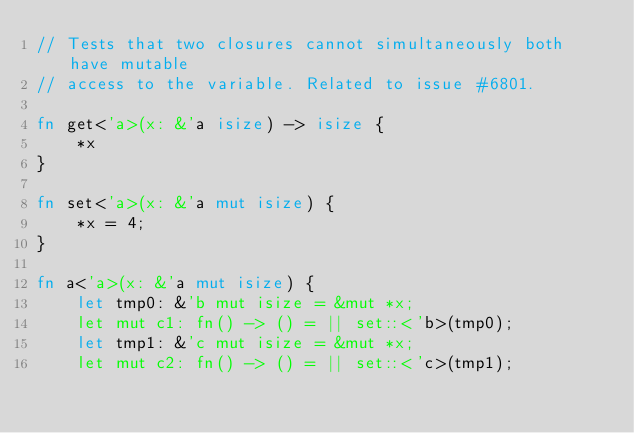Convert code to text. <code><loc_0><loc_0><loc_500><loc_500><_Rust_>// Tests that two closures cannot simultaneously both have mutable
// access to the variable. Related to issue #6801.

fn get<'a>(x: &'a isize) -> isize {
    *x
}

fn set<'a>(x: &'a mut isize) {
    *x = 4;
}

fn a<'a>(x: &'a mut isize) {
    let tmp0: &'b mut isize = &mut *x;
    let mut c1: fn() -> () = || set::<'b>(tmp0);
    let tmp1: &'c mut isize = &mut *x;
    let mut c2: fn() -> () = || set::<'c>(tmp1);</code> 